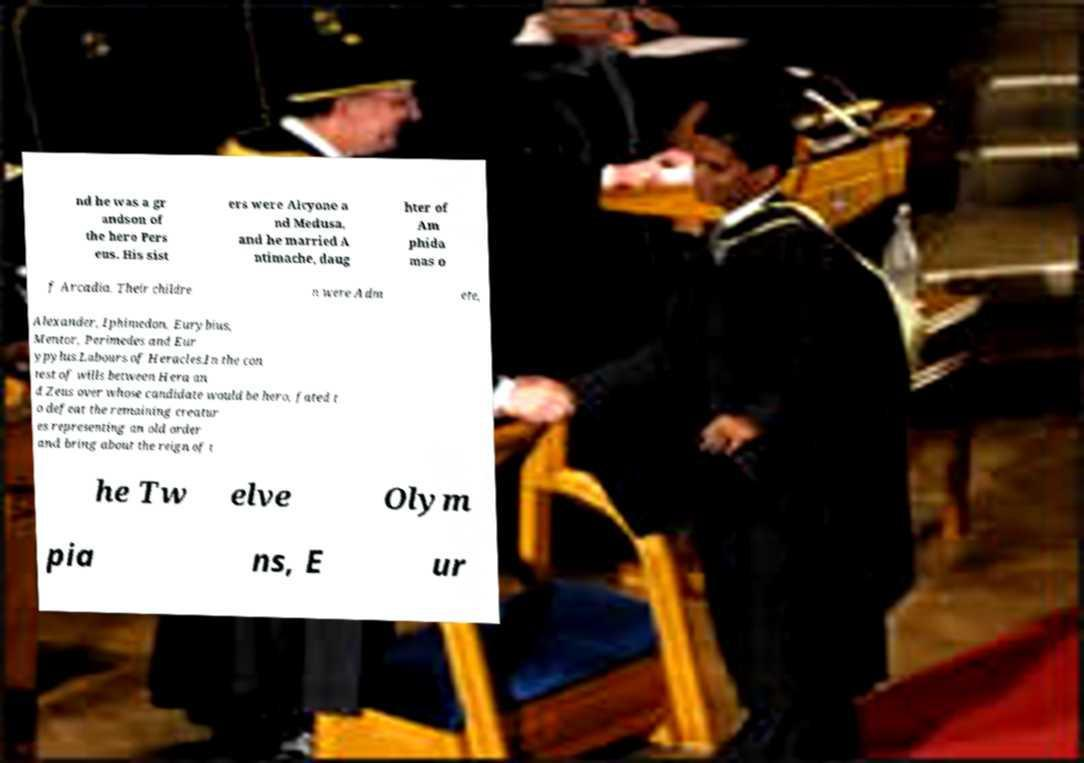Could you assist in decoding the text presented in this image and type it out clearly? nd he was a gr andson of the hero Pers eus. His sist ers were Alcyone a nd Medusa, and he married A ntimache, daug hter of Am phida mas o f Arcadia. Their childre n were Adm ete, Alexander, Iphimedon, Eurybius, Mentor, Perimedes and Eur ypylus.Labours of Heracles.In the con test of wills between Hera an d Zeus over whose candidate would be hero, fated t o defeat the remaining creatur es representing an old order and bring about the reign of t he Tw elve Olym pia ns, E ur 